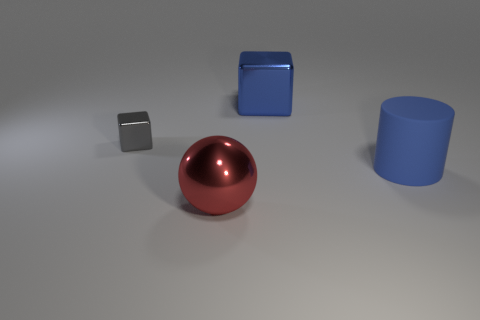Add 4 large matte cylinders. How many objects exist? 8 Subtract all balls. How many objects are left? 3 Add 1 big cyan balls. How many big cyan balls exist? 1 Subtract 0 yellow balls. How many objects are left? 4 Subtract all large yellow metal cylinders. Subtract all large red metal balls. How many objects are left? 3 Add 2 shiny objects. How many shiny objects are left? 5 